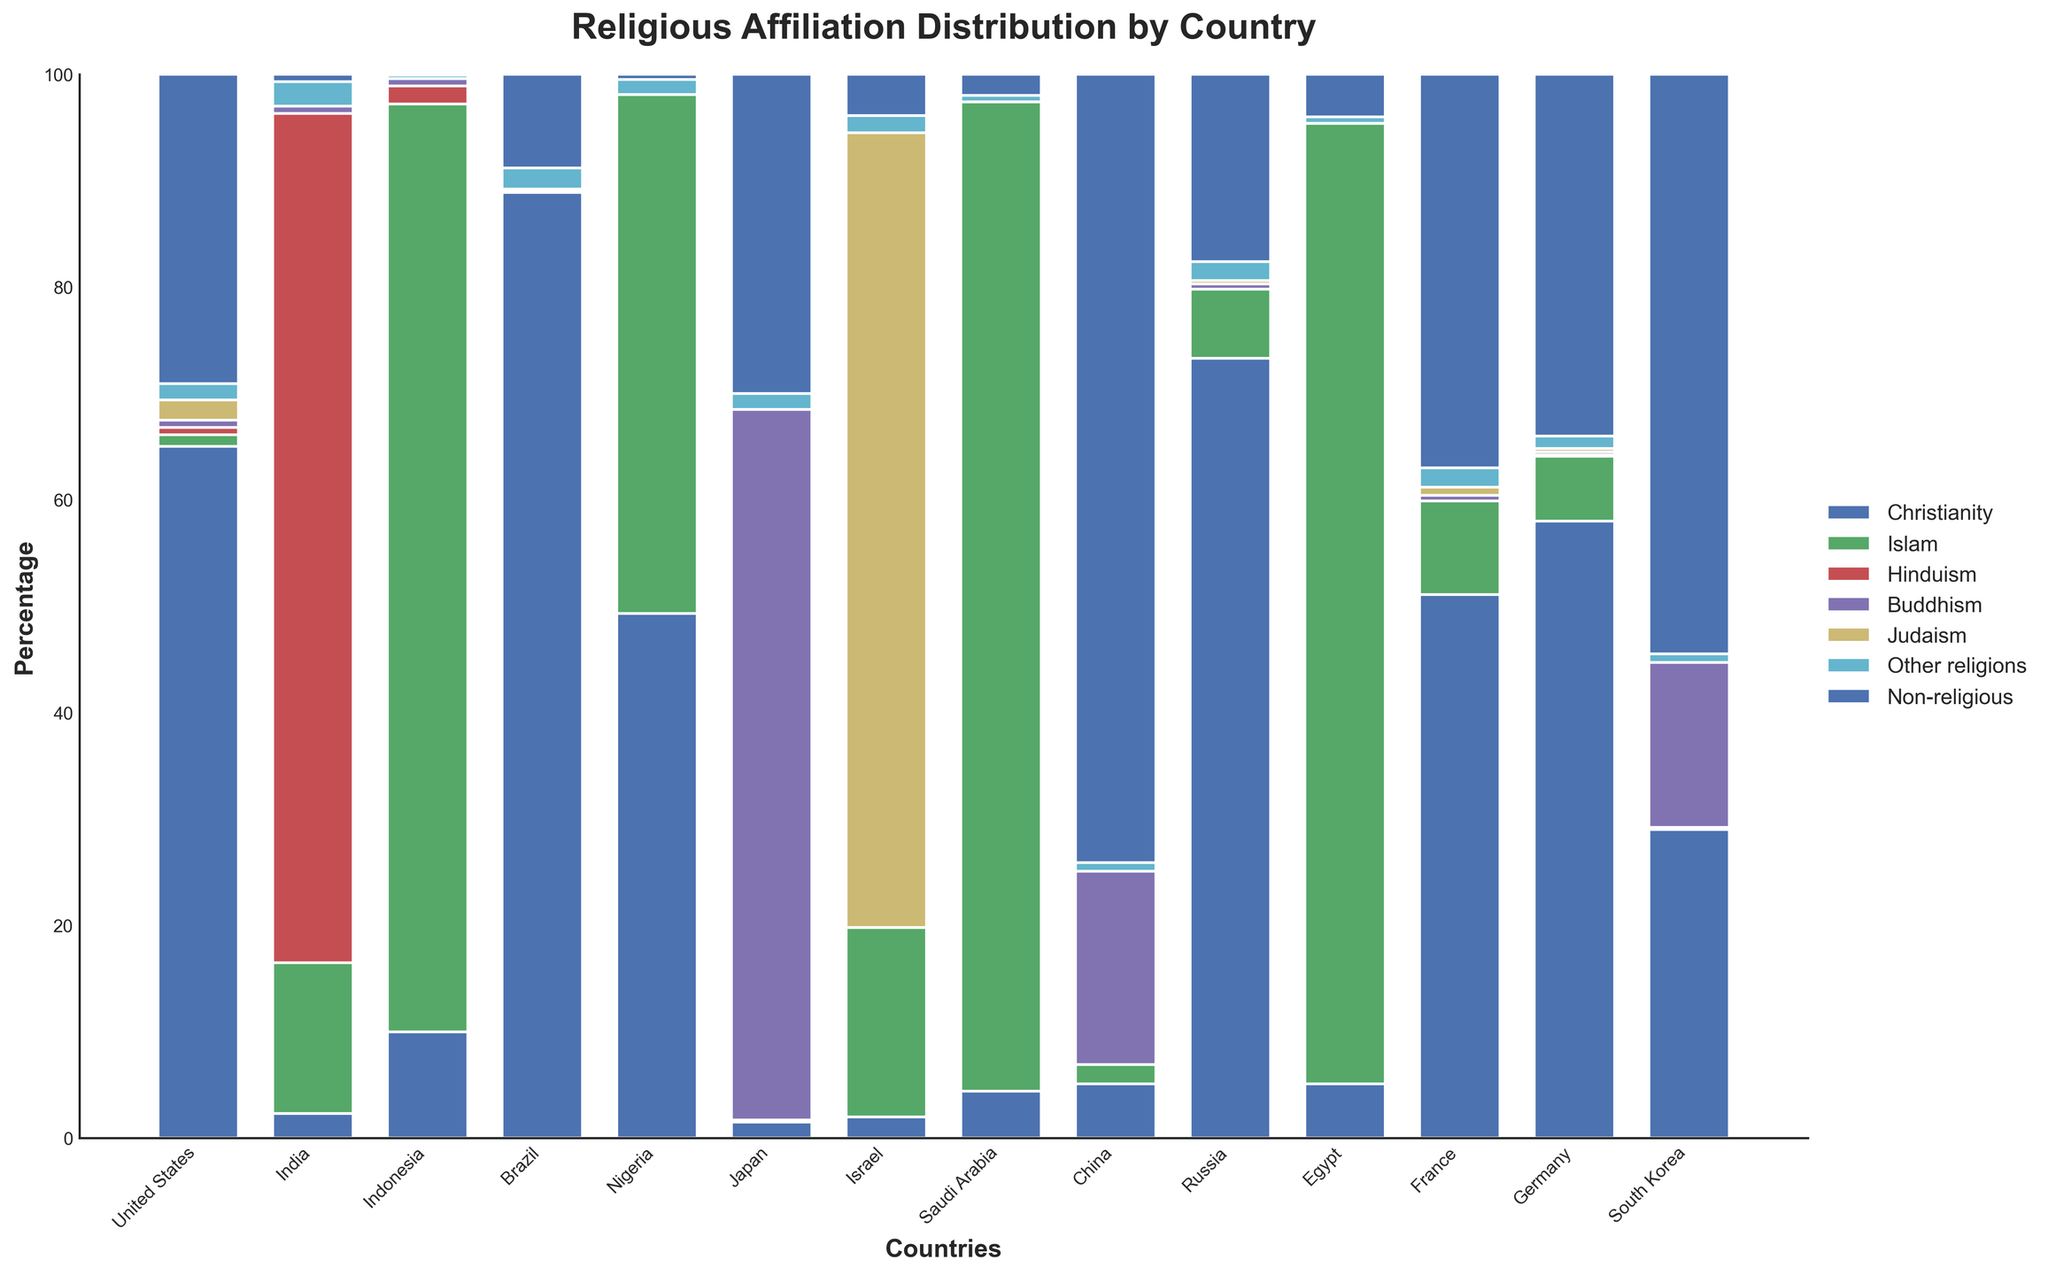What country has the highest percentage of Non-religious people? From the plot, find the tallest bar segment labeled "Non-religious" and identify its corresponding country. That country is China.
Answer: China Which country has a higher percentage of Buddhists: China or Japan? Compare the bar segments labeled "Buddhism" for both China and Japan. Japan's "Buddhism" segment is taller, indicating it has a higher percentage.
Answer: Japan What is the approximate total percentage of religious affiliations other than Non-religious in South Korea? Sum the percentages of all religions other than Non-religious for South Korea from the respective bar segments. (Christianity: 29.0, Buddhism: 15.5, and other minor religions) gives us a total.
Answer: Approximately 45.5% Between Russia and France, which country has a higher percentage of Christians? Compare the heights of the "Christianity" segments for Russia and France. Russia has the taller segment.
Answer: Russia How does the percentage of Jewish people in Israel compare to Judaism in other countries? Identify the country with the highest "Judaism" bar segment and then compare it to the segments in other countries. Israel has the largest segment, 74.7%, while other countries have much smaller values.
Answer: Israel has the highest percentage What is the combined percentage of Hinduism and Buddhism in India? Add the percentage values of "Hinduism" and "Buddhism" for India. Hinduism (79.8) + Buddhism (0.7) = 80.5
Answer: 80.5 Which country has the highest diversity in religious affiliations (considered as a mix of all present religions)? Visually inspect which country has a relatively uniform distribution across multiple religions. The United States shows a relatively varied distribution across several religions.
Answer: United States What is the difference between the percentages of Christians in Brazil and Nigeria? Subtract the percentage of Christians in Nigeria from that in Brazil. Brazil (88.9) - Nigeria (49.3) = 39.6
Answer: 39.6 In which country does Islam have the largest percentage, and what is that percentage? Identify the country with the tallest bar segment for "Islam." Saudi Arabia, with a percentage of 93.0, has the highest.
Answer: Saudi Arabia, 93.0% 